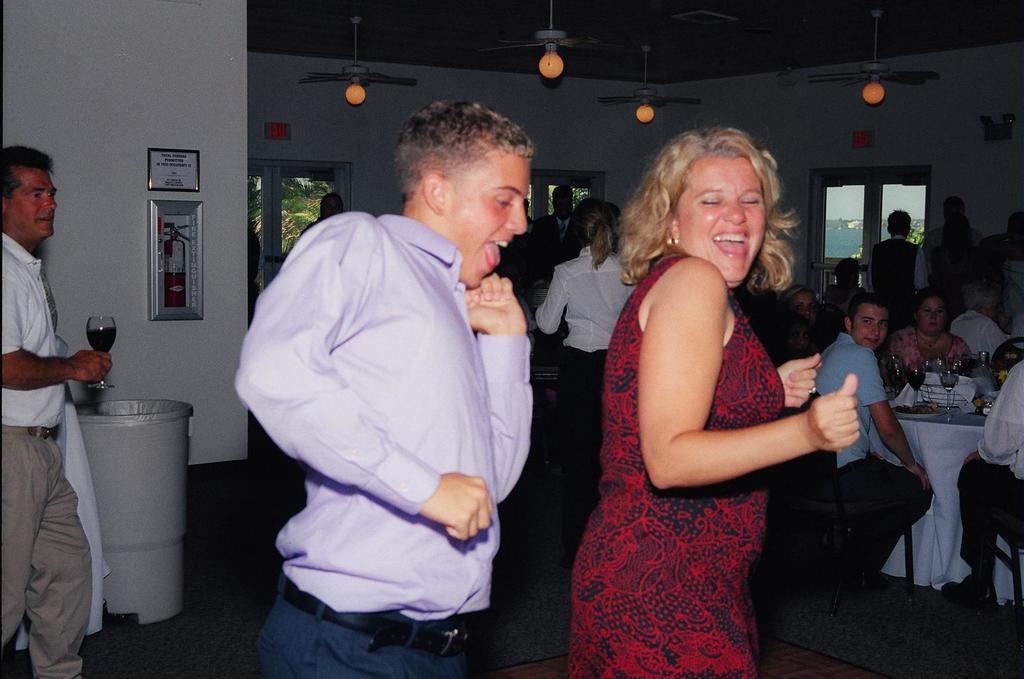In one or two sentences, can you explain what this image depicts? This picture is clicked in the restaurant. The man in violet shirt and the woman in red dress are dancing. Both of them are smiling. Behind them, we see people standing. On the right side, we see people sitting on the chairs. In front of them, we see a table on which plates containing food and glasses are placed. Behind them, we see a white wall and a window from which water can be visible. On the left side, the man in white T-shirt is holding a glass containing liquid in his hand. Beside him, we see a white wall on which photo frame and fire extinguisher are placed. 